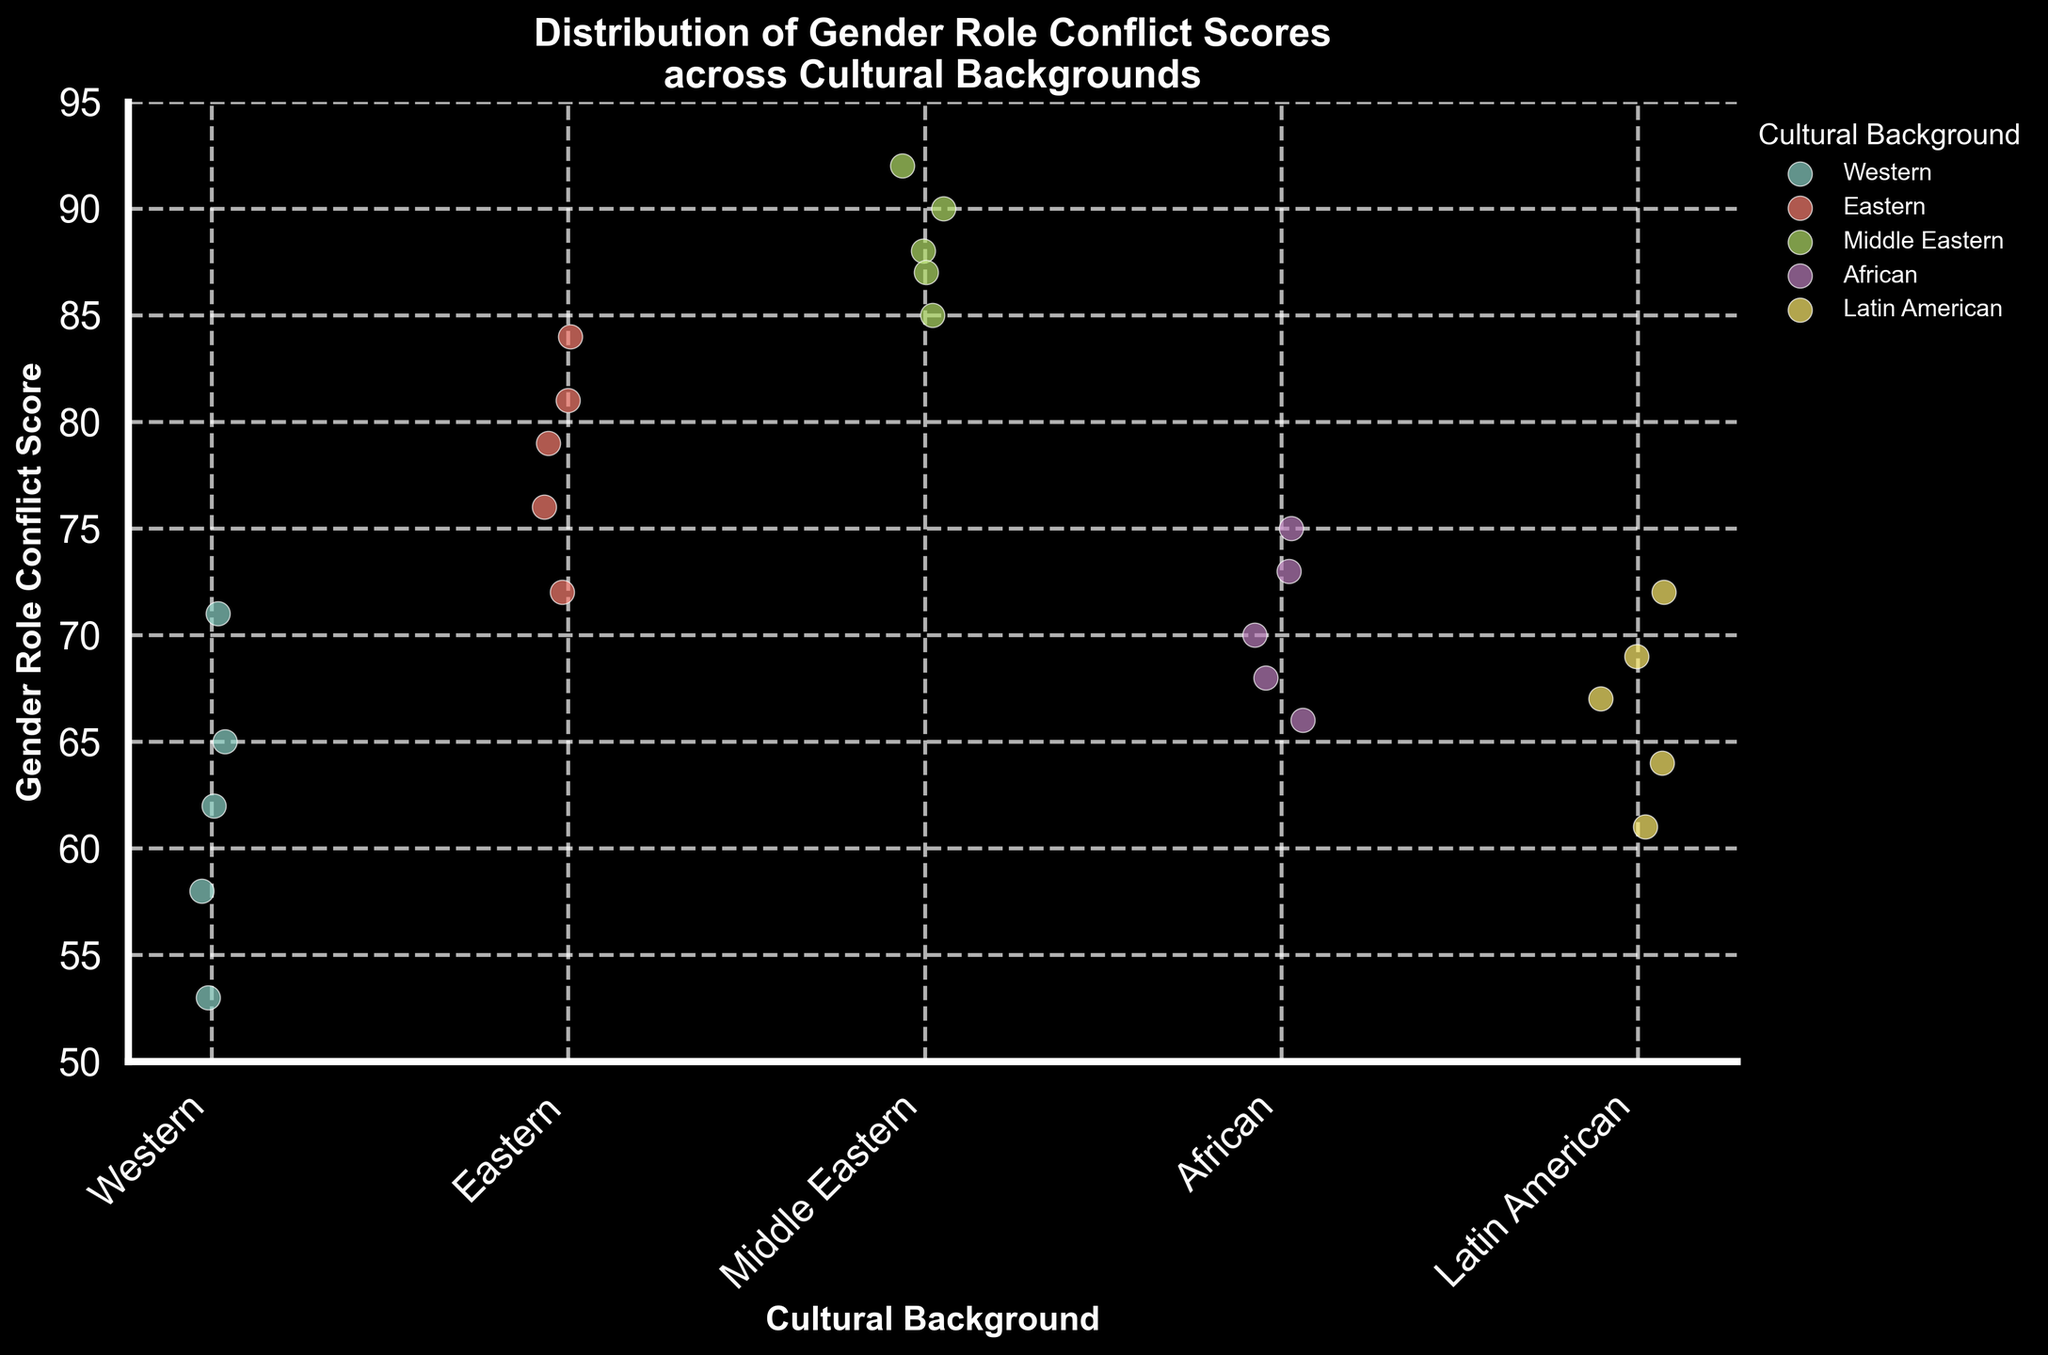What is the title of the figure? The title of the figure is written at the top of the plot. It reads "Distribution of Gender Role Conflict Scores across Cultural Backgrounds."
Answer: Distribution of Gender Role Conflict Scores across Cultural Backgrounds Which cultural background shows the highest Gender Role Conflict Scores? By looking at the scatter points, the Middle Eastern background has the highest scores, with values ranging from 85 to 92.
Answer: Middle Eastern How many data points are there in the Latin American group? In the Latin American group, you can count 5 individual scatter points.
Answer: 5 What is the range of Gender Role Conflict Scores for the Eastern group? To find the range, identify the minimum and maximum scores for the Eastern group, which are 72 and 84 respectively. The range is calculated as 84 - 72 = 12.
Answer: 12 Which group has the lowest minimum score, and what is that score? By comparing the lowest points in each group, the Western group has the lowest minimum score of 53.
Answer: Western, 53 What is the average Gender Role Conflict Score for the African group? Sum the scores of the African group (70, 75, 68, 73, 66) and divide by the number of scores: (70 + 75 + 68 + 73 + 66) / 5 = 70.4.
Answer: 70.4 Do the Western and African groups have any overlapping scores? Compare the score ranges of both groups. Western (53-71), African (66-75). They overlap between 66 and 71.
Answer: Yes Which cultural background has the most spread in scores? To determine the spread, calculate the range for each group: Western (71-53=18), Eastern (84-72=12), Middle Eastern (92-85=7), African (75-66=9), Latin American (72-61=11). Western has the largest range of 18.
Answer: Western Is there a trend in the Gender Role Conflict Scores as you move from Western to Middle Eastern backgrounds? As you visually follow the scatter points from Western to Middle Eastern, scores appear to increase in general, indicating an upward trend.
Answer: Scores generally increase In which group are the data points most densely packed? By observing the clustering of scatter points, the Middle Eastern group shows the most dense packing, indicating less variability in scores.
Answer: Middle Eastern 